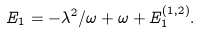Convert formula to latex. <formula><loc_0><loc_0><loc_500><loc_500>E _ { 1 } = - \lambda ^ { 2 } / \omega + \omega + E _ { 1 } ^ { ( 1 , 2 ) } .</formula> 